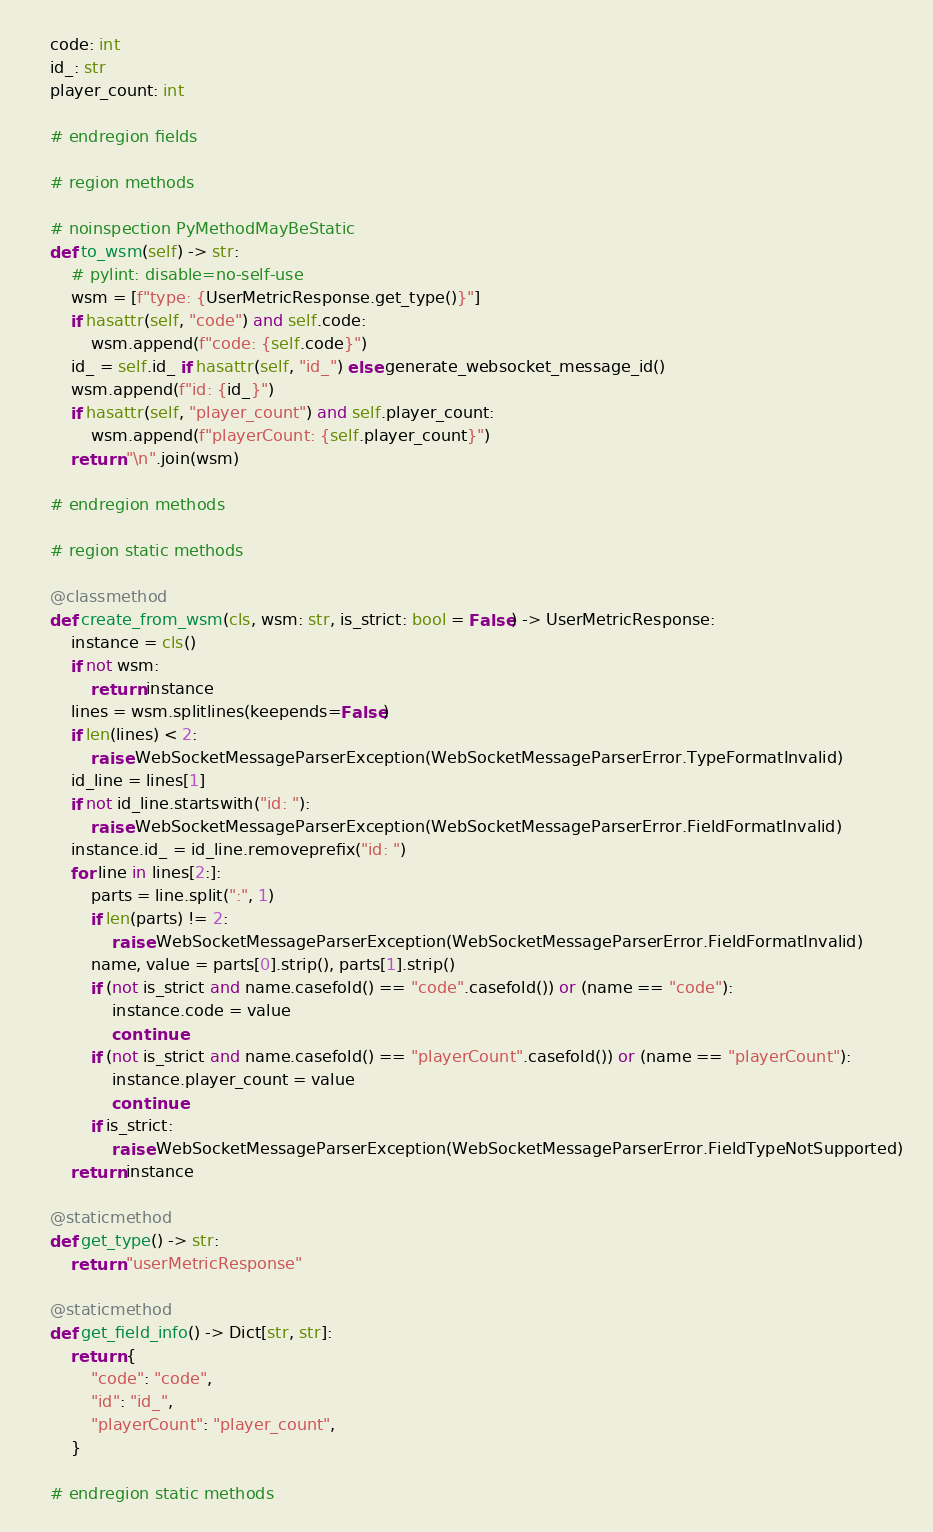Convert code to text. <code><loc_0><loc_0><loc_500><loc_500><_Python_>
    code: int
    id_: str
    player_count: int

    # endregion fields

    # region methods

    # noinspection PyMethodMayBeStatic
    def to_wsm(self) -> str:
        # pylint: disable=no-self-use
        wsm = [f"type: {UserMetricResponse.get_type()}"]
        if hasattr(self, "code") and self.code:
            wsm.append(f"code: {self.code}")
        id_ = self.id_ if hasattr(self, "id_") else generate_websocket_message_id()
        wsm.append(f"id: {id_}")
        if hasattr(self, "player_count") and self.player_count:
            wsm.append(f"playerCount: {self.player_count}")
        return "\n".join(wsm)

    # endregion methods

    # region static methods

    @classmethod
    def create_from_wsm(cls, wsm: str, is_strict: bool = False) -> UserMetricResponse:
        instance = cls()
        if not wsm:
            return instance
        lines = wsm.splitlines(keepends=False)
        if len(lines) < 2:
            raise WebSocketMessageParserException(WebSocketMessageParserError.TypeFormatInvalid)
        id_line = lines[1]
        if not id_line.startswith("id: "):
            raise WebSocketMessageParserException(WebSocketMessageParserError.FieldFormatInvalid)
        instance.id_ = id_line.removeprefix("id: ")
        for line in lines[2:]:
            parts = line.split(":", 1)
            if len(parts) != 2:
                raise WebSocketMessageParserException(WebSocketMessageParserError.FieldFormatInvalid)
            name, value = parts[0].strip(), parts[1].strip()
            if (not is_strict and name.casefold() == "code".casefold()) or (name == "code"):
                instance.code = value
                continue
            if (not is_strict and name.casefold() == "playerCount".casefold()) or (name == "playerCount"):
                instance.player_count = value
                continue
            if is_strict:
                raise WebSocketMessageParserException(WebSocketMessageParserError.FieldTypeNotSupported)
        return instance

    @staticmethod
    def get_type() -> str:
        return "userMetricResponse"

    @staticmethod
    def get_field_info() -> Dict[str, str]:
        return {
            "code": "code",
            "id": "id_",
            "playerCount": "player_count",
        }

    # endregion static methods
</code> 